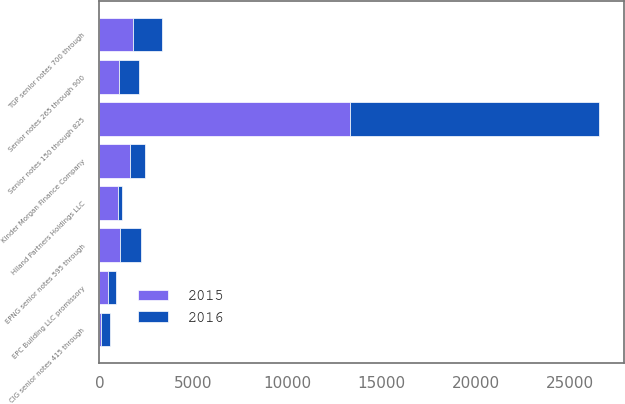Convert chart to OTSL. <chart><loc_0><loc_0><loc_500><loc_500><stacked_bar_chart><ecel><fcel>Senior notes 150 through 825<fcel>Senior notes 265 through 900<fcel>TGP senior notes 700 through<fcel>EPNG senior notes 595 through<fcel>CIG senior notes 415 through<fcel>Kinder Morgan Finance Company<fcel>Hiland Partners Holdings LLC<fcel>EPC Building LLC promissory<nl><fcel>2016<fcel>13236<fcel>1044.5<fcel>1540<fcel>1115<fcel>475<fcel>786<fcel>225<fcel>433<nl><fcel>2015<fcel>13346<fcel>1044.5<fcel>1790<fcel>1115<fcel>100<fcel>1636<fcel>974<fcel>443<nl></chart> 